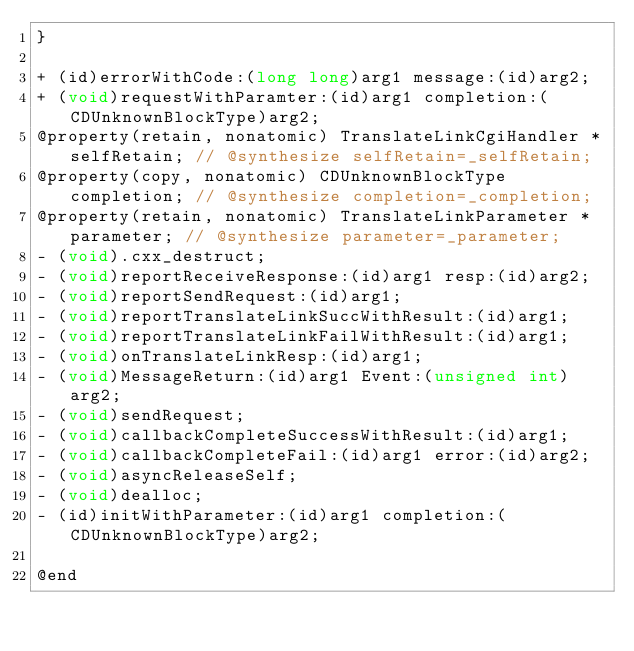<code> <loc_0><loc_0><loc_500><loc_500><_C_>}

+ (id)errorWithCode:(long long)arg1 message:(id)arg2;
+ (void)requestWithParamter:(id)arg1 completion:(CDUnknownBlockType)arg2;
@property(retain, nonatomic) TranslateLinkCgiHandler *selfRetain; // @synthesize selfRetain=_selfRetain;
@property(copy, nonatomic) CDUnknownBlockType completion; // @synthesize completion=_completion;
@property(retain, nonatomic) TranslateLinkParameter *parameter; // @synthesize parameter=_parameter;
- (void).cxx_destruct;
- (void)reportReceiveResponse:(id)arg1 resp:(id)arg2;
- (void)reportSendRequest:(id)arg1;
- (void)reportTranslateLinkSuccWithResult:(id)arg1;
- (void)reportTranslateLinkFailWithResult:(id)arg1;
- (void)onTranslateLinkResp:(id)arg1;
- (void)MessageReturn:(id)arg1 Event:(unsigned int)arg2;
- (void)sendRequest;
- (void)callbackCompleteSuccessWithResult:(id)arg1;
- (void)callbackCompleteFail:(id)arg1 error:(id)arg2;
- (void)asyncReleaseSelf;
- (void)dealloc;
- (id)initWithParameter:(id)arg1 completion:(CDUnknownBlockType)arg2;

@end

</code> 